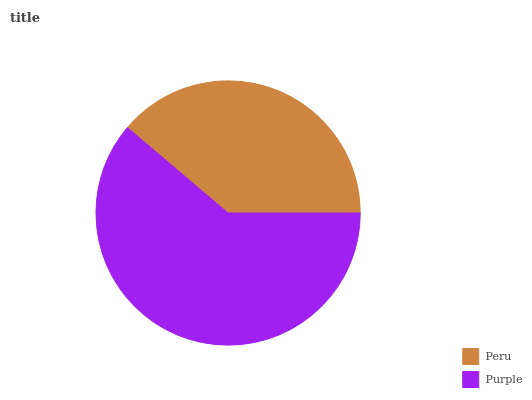Is Peru the minimum?
Answer yes or no. Yes. Is Purple the maximum?
Answer yes or no. Yes. Is Purple the minimum?
Answer yes or no. No. Is Purple greater than Peru?
Answer yes or no. Yes. Is Peru less than Purple?
Answer yes or no. Yes. Is Peru greater than Purple?
Answer yes or no. No. Is Purple less than Peru?
Answer yes or no. No. Is Purple the high median?
Answer yes or no. Yes. Is Peru the low median?
Answer yes or no. Yes. Is Peru the high median?
Answer yes or no. No. Is Purple the low median?
Answer yes or no. No. 